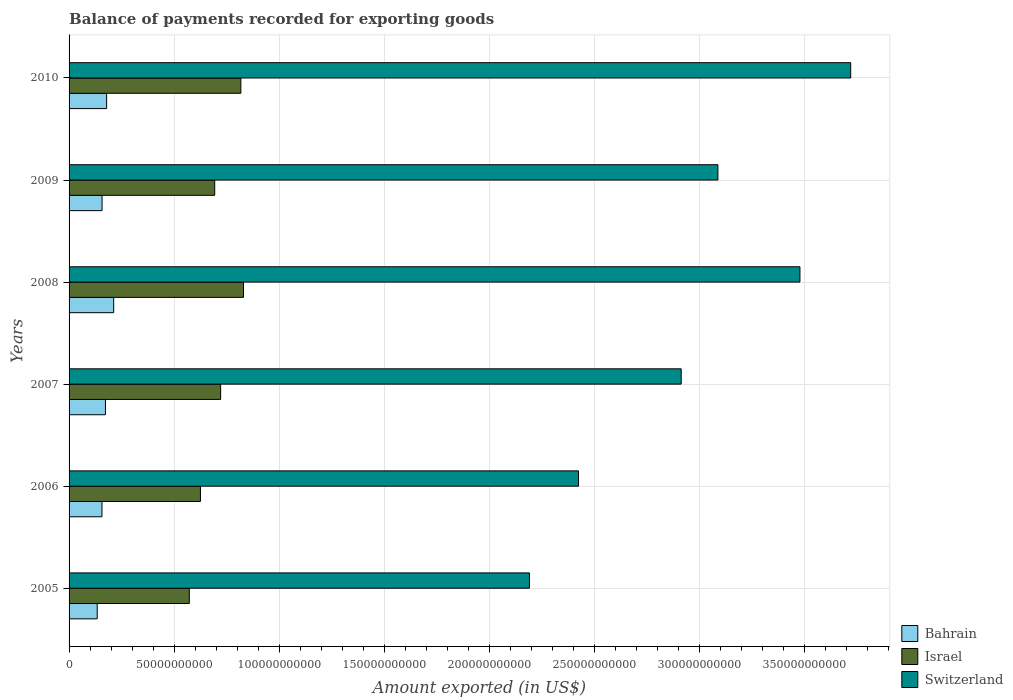How many groups of bars are there?
Keep it short and to the point. 6. Are the number of bars per tick equal to the number of legend labels?
Offer a terse response. Yes. What is the label of the 3rd group of bars from the top?
Offer a very short reply. 2008. What is the amount exported in Switzerland in 2005?
Give a very brief answer. 2.19e+11. Across all years, what is the maximum amount exported in Bahrain?
Provide a succinct answer. 2.12e+1. Across all years, what is the minimum amount exported in Switzerland?
Your answer should be very brief. 2.19e+11. In which year was the amount exported in Israel minimum?
Ensure brevity in your answer.  2005. What is the total amount exported in Switzerland in the graph?
Offer a very short reply. 1.78e+12. What is the difference between the amount exported in Bahrain in 2006 and that in 2009?
Make the answer very short. -4.25e+07. What is the difference between the amount exported in Switzerland in 2006 and the amount exported in Israel in 2007?
Provide a succinct answer. 1.70e+11. What is the average amount exported in Bahrain per year?
Keep it short and to the point. 1.69e+1. In the year 2010, what is the difference between the amount exported in Bahrain and amount exported in Switzerland?
Your answer should be very brief. -3.54e+11. In how many years, is the amount exported in Switzerland greater than 330000000000 US$?
Provide a succinct answer. 2. What is the ratio of the amount exported in Israel in 2009 to that in 2010?
Ensure brevity in your answer.  0.85. What is the difference between the highest and the second highest amount exported in Israel?
Make the answer very short. 1.26e+09. What is the difference between the highest and the lowest amount exported in Israel?
Ensure brevity in your answer.  2.58e+1. Is the sum of the amount exported in Bahrain in 2008 and 2009 greater than the maximum amount exported in Switzerland across all years?
Keep it short and to the point. No. What does the 3rd bar from the top in 2008 represents?
Give a very brief answer. Bahrain. What does the 3rd bar from the bottom in 2010 represents?
Your answer should be very brief. Switzerland. Is it the case that in every year, the sum of the amount exported in Israel and amount exported in Switzerland is greater than the amount exported in Bahrain?
Your answer should be very brief. Yes. How many bars are there?
Ensure brevity in your answer.  18. What is the difference between two consecutive major ticks on the X-axis?
Give a very brief answer. 5.00e+1. How are the legend labels stacked?
Your answer should be compact. Vertical. What is the title of the graph?
Your response must be concise. Balance of payments recorded for exporting goods. Does "Lithuania" appear as one of the legend labels in the graph?
Provide a succinct answer. No. What is the label or title of the X-axis?
Give a very brief answer. Amount exported (in US$). What is the label or title of the Y-axis?
Provide a short and direct response. Years. What is the Amount exported (in US$) of Bahrain in 2005?
Your answer should be very brief. 1.34e+1. What is the Amount exported (in US$) in Israel in 2005?
Offer a terse response. 5.72e+1. What is the Amount exported (in US$) of Switzerland in 2005?
Provide a succinct answer. 2.19e+11. What is the Amount exported (in US$) of Bahrain in 2006?
Your answer should be compact. 1.57e+1. What is the Amount exported (in US$) in Israel in 2006?
Give a very brief answer. 6.26e+1. What is the Amount exported (in US$) of Switzerland in 2006?
Provide a short and direct response. 2.43e+11. What is the Amount exported (in US$) of Bahrain in 2007?
Your answer should be very brief. 1.73e+1. What is the Amount exported (in US$) of Israel in 2007?
Your answer should be very brief. 7.22e+1. What is the Amount exported (in US$) in Switzerland in 2007?
Give a very brief answer. 2.91e+11. What is the Amount exported (in US$) of Bahrain in 2008?
Give a very brief answer. 2.12e+1. What is the Amount exported (in US$) of Israel in 2008?
Provide a short and direct response. 8.30e+1. What is the Amount exported (in US$) in Switzerland in 2008?
Offer a very short reply. 3.48e+11. What is the Amount exported (in US$) in Bahrain in 2009?
Provide a succinct answer. 1.57e+1. What is the Amount exported (in US$) in Israel in 2009?
Provide a succinct answer. 6.93e+1. What is the Amount exported (in US$) in Switzerland in 2009?
Offer a terse response. 3.09e+11. What is the Amount exported (in US$) in Bahrain in 2010?
Make the answer very short. 1.79e+1. What is the Amount exported (in US$) in Israel in 2010?
Your answer should be compact. 8.18e+1. What is the Amount exported (in US$) of Switzerland in 2010?
Provide a succinct answer. 3.72e+11. Across all years, what is the maximum Amount exported (in US$) of Bahrain?
Offer a terse response. 2.12e+1. Across all years, what is the maximum Amount exported (in US$) of Israel?
Your response must be concise. 8.30e+1. Across all years, what is the maximum Amount exported (in US$) in Switzerland?
Your answer should be very brief. 3.72e+11. Across all years, what is the minimum Amount exported (in US$) in Bahrain?
Give a very brief answer. 1.34e+1. Across all years, what is the minimum Amount exported (in US$) in Israel?
Make the answer very short. 5.72e+1. Across all years, what is the minimum Amount exported (in US$) in Switzerland?
Your response must be concise. 2.19e+11. What is the total Amount exported (in US$) of Bahrain in the graph?
Offer a very short reply. 1.01e+11. What is the total Amount exported (in US$) in Israel in the graph?
Your answer should be compact. 4.26e+11. What is the total Amount exported (in US$) of Switzerland in the graph?
Keep it short and to the point. 1.78e+12. What is the difference between the Amount exported (in US$) in Bahrain in 2005 and that in 2006?
Make the answer very short. -2.27e+09. What is the difference between the Amount exported (in US$) in Israel in 2005 and that in 2006?
Provide a succinct answer. -5.30e+09. What is the difference between the Amount exported (in US$) in Switzerland in 2005 and that in 2006?
Ensure brevity in your answer.  -2.34e+1. What is the difference between the Amount exported (in US$) of Bahrain in 2005 and that in 2007?
Your answer should be very brief. -3.92e+09. What is the difference between the Amount exported (in US$) in Israel in 2005 and that in 2007?
Offer a very short reply. -1.49e+1. What is the difference between the Amount exported (in US$) in Switzerland in 2005 and that in 2007?
Give a very brief answer. -7.23e+1. What is the difference between the Amount exported (in US$) of Bahrain in 2005 and that in 2008?
Your answer should be very brief. -7.83e+09. What is the difference between the Amount exported (in US$) of Israel in 2005 and that in 2008?
Ensure brevity in your answer.  -2.58e+1. What is the difference between the Amount exported (in US$) in Switzerland in 2005 and that in 2008?
Your response must be concise. -1.29e+11. What is the difference between the Amount exported (in US$) in Bahrain in 2005 and that in 2009?
Offer a very short reply. -2.31e+09. What is the difference between the Amount exported (in US$) of Israel in 2005 and that in 2009?
Your response must be concise. -1.21e+1. What is the difference between the Amount exported (in US$) in Switzerland in 2005 and that in 2009?
Provide a succinct answer. -8.97e+1. What is the difference between the Amount exported (in US$) in Bahrain in 2005 and that in 2010?
Your answer should be very brief. -4.48e+09. What is the difference between the Amount exported (in US$) in Israel in 2005 and that in 2010?
Ensure brevity in your answer.  -2.45e+1. What is the difference between the Amount exported (in US$) of Switzerland in 2005 and that in 2010?
Provide a short and direct response. -1.53e+11. What is the difference between the Amount exported (in US$) of Bahrain in 2006 and that in 2007?
Offer a very short reply. -1.65e+09. What is the difference between the Amount exported (in US$) of Israel in 2006 and that in 2007?
Provide a succinct answer. -9.61e+09. What is the difference between the Amount exported (in US$) in Switzerland in 2006 and that in 2007?
Make the answer very short. -4.89e+1. What is the difference between the Amount exported (in US$) of Bahrain in 2006 and that in 2008?
Offer a terse response. -5.57e+09. What is the difference between the Amount exported (in US$) in Israel in 2006 and that in 2008?
Provide a short and direct response. -2.05e+1. What is the difference between the Amount exported (in US$) of Switzerland in 2006 and that in 2008?
Make the answer very short. -1.05e+11. What is the difference between the Amount exported (in US$) in Bahrain in 2006 and that in 2009?
Make the answer very short. -4.25e+07. What is the difference between the Amount exported (in US$) of Israel in 2006 and that in 2009?
Keep it short and to the point. -6.79e+09. What is the difference between the Amount exported (in US$) in Switzerland in 2006 and that in 2009?
Provide a succinct answer. -6.64e+1. What is the difference between the Amount exported (in US$) in Bahrain in 2006 and that in 2010?
Offer a very short reply. -2.22e+09. What is the difference between the Amount exported (in US$) of Israel in 2006 and that in 2010?
Ensure brevity in your answer.  -1.92e+1. What is the difference between the Amount exported (in US$) in Switzerland in 2006 and that in 2010?
Provide a short and direct response. -1.30e+11. What is the difference between the Amount exported (in US$) of Bahrain in 2007 and that in 2008?
Your answer should be very brief. -3.92e+09. What is the difference between the Amount exported (in US$) of Israel in 2007 and that in 2008?
Offer a very short reply. -1.09e+1. What is the difference between the Amount exported (in US$) of Switzerland in 2007 and that in 2008?
Your response must be concise. -5.65e+1. What is the difference between the Amount exported (in US$) in Bahrain in 2007 and that in 2009?
Offer a very short reply. 1.61e+09. What is the difference between the Amount exported (in US$) in Israel in 2007 and that in 2009?
Your answer should be very brief. 2.82e+09. What is the difference between the Amount exported (in US$) in Switzerland in 2007 and that in 2009?
Your response must be concise. -1.75e+1. What is the difference between the Amount exported (in US$) in Bahrain in 2007 and that in 2010?
Keep it short and to the point. -5.66e+08. What is the difference between the Amount exported (in US$) of Israel in 2007 and that in 2010?
Offer a terse response. -9.62e+09. What is the difference between the Amount exported (in US$) of Switzerland in 2007 and that in 2010?
Provide a short and direct response. -8.07e+1. What is the difference between the Amount exported (in US$) in Bahrain in 2008 and that in 2009?
Your answer should be very brief. 5.53e+09. What is the difference between the Amount exported (in US$) in Israel in 2008 and that in 2009?
Offer a very short reply. 1.37e+1. What is the difference between the Amount exported (in US$) of Switzerland in 2008 and that in 2009?
Your answer should be very brief. 3.91e+1. What is the difference between the Amount exported (in US$) in Bahrain in 2008 and that in 2010?
Your answer should be compact. 3.35e+09. What is the difference between the Amount exported (in US$) in Israel in 2008 and that in 2010?
Offer a terse response. 1.26e+09. What is the difference between the Amount exported (in US$) in Switzerland in 2008 and that in 2010?
Your response must be concise. -2.42e+1. What is the difference between the Amount exported (in US$) in Bahrain in 2009 and that in 2010?
Provide a short and direct response. -2.18e+09. What is the difference between the Amount exported (in US$) of Israel in 2009 and that in 2010?
Ensure brevity in your answer.  -1.24e+1. What is the difference between the Amount exported (in US$) of Switzerland in 2009 and that in 2010?
Make the answer very short. -6.32e+1. What is the difference between the Amount exported (in US$) of Bahrain in 2005 and the Amount exported (in US$) of Israel in 2006?
Provide a short and direct response. -4.92e+1. What is the difference between the Amount exported (in US$) of Bahrain in 2005 and the Amount exported (in US$) of Switzerland in 2006?
Give a very brief answer. -2.29e+11. What is the difference between the Amount exported (in US$) of Israel in 2005 and the Amount exported (in US$) of Switzerland in 2006?
Your response must be concise. -1.85e+11. What is the difference between the Amount exported (in US$) in Bahrain in 2005 and the Amount exported (in US$) in Israel in 2007?
Offer a terse response. -5.88e+1. What is the difference between the Amount exported (in US$) in Bahrain in 2005 and the Amount exported (in US$) in Switzerland in 2007?
Your answer should be compact. -2.78e+11. What is the difference between the Amount exported (in US$) of Israel in 2005 and the Amount exported (in US$) of Switzerland in 2007?
Your answer should be very brief. -2.34e+11. What is the difference between the Amount exported (in US$) in Bahrain in 2005 and the Amount exported (in US$) in Israel in 2008?
Provide a short and direct response. -6.96e+1. What is the difference between the Amount exported (in US$) of Bahrain in 2005 and the Amount exported (in US$) of Switzerland in 2008?
Provide a short and direct response. -3.35e+11. What is the difference between the Amount exported (in US$) of Israel in 2005 and the Amount exported (in US$) of Switzerland in 2008?
Make the answer very short. -2.91e+11. What is the difference between the Amount exported (in US$) in Bahrain in 2005 and the Amount exported (in US$) in Israel in 2009?
Make the answer very short. -5.59e+1. What is the difference between the Amount exported (in US$) of Bahrain in 2005 and the Amount exported (in US$) of Switzerland in 2009?
Provide a short and direct response. -2.96e+11. What is the difference between the Amount exported (in US$) in Israel in 2005 and the Amount exported (in US$) in Switzerland in 2009?
Ensure brevity in your answer.  -2.52e+11. What is the difference between the Amount exported (in US$) in Bahrain in 2005 and the Amount exported (in US$) in Israel in 2010?
Your answer should be very brief. -6.84e+1. What is the difference between the Amount exported (in US$) in Bahrain in 2005 and the Amount exported (in US$) in Switzerland in 2010?
Your answer should be very brief. -3.59e+11. What is the difference between the Amount exported (in US$) of Israel in 2005 and the Amount exported (in US$) of Switzerland in 2010?
Your answer should be very brief. -3.15e+11. What is the difference between the Amount exported (in US$) of Bahrain in 2006 and the Amount exported (in US$) of Israel in 2007?
Your answer should be compact. -5.65e+1. What is the difference between the Amount exported (in US$) of Bahrain in 2006 and the Amount exported (in US$) of Switzerland in 2007?
Ensure brevity in your answer.  -2.76e+11. What is the difference between the Amount exported (in US$) in Israel in 2006 and the Amount exported (in US$) in Switzerland in 2007?
Offer a terse response. -2.29e+11. What is the difference between the Amount exported (in US$) in Bahrain in 2006 and the Amount exported (in US$) in Israel in 2008?
Your answer should be compact. -6.74e+1. What is the difference between the Amount exported (in US$) in Bahrain in 2006 and the Amount exported (in US$) in Switzerland in 2008?
Your response must be concise. -3.32e+11. What is the difference between the Amount exported (in US$) in Israel in 2006 and the Amount exported (in US$) in Switzerland in 2008?
Ensure brevity in your answer.  -2.85e+11. What is the difference between the Amount exported (in US$) in Bahrain in 2006 and the Amount exported (in US$) in Israel in 2009?
Your answer should be compact. -5.37e+1. What is the difference between the Amount exported (in US$) in Bahrain in 2006 and the Amount exported (in US$) in Switzerland in 2009?
Your answer should be compact. -2.93e+11. What is the difference between the Amount exported (in US$) in Israel in 2006 and the Amount exported (in US$) in Switzerland in 2009?
Provide a short and direct response. -2.46e+11. What is the difference between the Amount exported (in US$) in Bahrain in 2006 and the Amount exported (in US$) in Israel in 2010?
Make the answer very short. -6.61e+1. What is the difference between the Amount exported (in US$) of Bahrain in 2006 and the Amount exported (in US$) of Switzerland in 2010?
Make the answer very short. -3.56e+11. What is the difference between the Amount exported (in US$) in Israel in 2006 and the Amount exported (in US$) in Switzerland in 2010?
Offer a very short reply. -3.10e+11. What is the difference between the Amount exported (in US$) in Bahrain in 2007 and the Amount exported (in US$) in Israel in 2008?
Your answer should be very brief. -6.57e+1. What is the difference between the Amount exported (in US$) of Bahrain in 2007 and the Amount exported (in US$) of Switzerland in 2008?
Keep it short and to the point. -3.31e+11. What is the difference between the Amount exported (in US$) of Israel in 2007 and the Amount exported (in US$) of Switzerland in 2008?
Your response must be concise. -2.76e+11. What is the difference between the Amount exported (in US$) in Bahrain in 2007 and the Amount exported (in US$) in Israel in 2009?
Ensure brevity in your answer.  -5.20e+1. What is the difference between the Amount exported (in US$) of Bahrain in 2007 and the Amount exported (in US$) of Switzerland in 2009?
Ensure brevity in your answer.  -2.92e+11. What is the difference between the Amount exported (in US$) of Israel in 2007 and the Amount exported (in US$) of Switzerland in 2009?
Your answer should be compact. -2.37e+11. What is the difference between the Amount exported (in US$) in Bahrain in 2007 and the Amount exported (in US$) in Israel in 2010?
Offer a very short reply. -6.45e+1. What is the difference between the Amount exported (in US$) of Bahrain in 2007 and the Amount exported (in US$) of Switzerland in 2010?
Your response must be concise. -3.55e+11. What is the difference between the Amount exported (in US$) of Israel in 2007 and the Amount exported (in US$) of Switzerland in 2010?
Your response must be concise. -3.00e+11. What is the difference between the Amount exported (in US$) of Bahrain in 2008 and the Amount exported (in US$) of Israel in 2009?
Provide a short and direct response. -4.81e+1. What is the difference between the Amount exported (in US$) of Bahrain in 2008 and the Amount exported (in US$) of Switzerland in 2009?
Provide a succinct answer. -2.88e+11. What is the difference between the Amount exported (in US$) in Israel in 2008 and the Amount exported (in US$) in Switzerland in 2009?
Provide a short and direct response. -2.26e+11. What is the difference between the Amount exported (in US$) of Bahrain in 2008 and the Amount exported (in US$) of Israel in 2010?
Your response must be concise. -6.06e+1. What is the difference between the Amount exported (in US$) of Bahrain in 2008 and the Amount exported (in US$) of Switzerland in 2010?
Keep it short and to the point. -3.51e+11. What is the difference between the Amount exported (in US$) of Israel in 2008 and the Amount exported (in US$) of Switzerland in 2010?
Provide a succinct answer. -2.89e+11. What is the difference between the Amount exported (in US$) in Bahrain in 2009 and the Amount exported (in US$) in Israel in 2010?
Provide a short and direct response. -6.61e+1. What is the difference between the Amount exported (in US$) of Bahrain in 2009 and the Amount exported (in US$) of Switzerland in 2010?
Provide a succinct answer. -3.56e+11. What is the difference between the Amount exported (in US$) in Israel in 2009 and the Amount exported (in US$) in Switzerland in 2010?
Make the answer very short. -3.03e+11. What is the average Amount exported (in US$) in Bahrain per year?
Provide a short and direct response. 1.69e+1. What is the average Amount exported (in US$) of Israel per year?
Provide a succinct answer. 7.10e+1. What is the average Amount exported (in US$) of Switzerland per year?
Provide a succinct answer. 2.97e+11. In the year 2005, what is the difference between the Amount exported (in US$) of Bahrain and Amount exported (in US$) of Israel?
Your answer should be compact. -4.39e+1. In the year 2005, what is the difference between the Amount exported (in US$) of Bahrain and Amount exported (in US$) of Switzerland?
Offer a terse response. -2.06e+11. In the year 2005, what is the difference between the Amount exported (in US$) of Israel and Amount exported (in US$) of Switzerland?
Provide a succinct answer. -1.62e+11. In the year 2006, what is the difference between the Amount exported (in US$) in Bahrain and Amount exported (in US$) in Israel?
Offer a very short reply. -4.69e+1. In the year 2006, what is the difference between the Amount exported (in US$) of Bahrain and Amount exported (in US$) of Switzerland?
Ensure brevity in your answer.  -2.27e+11. In the year 2006, what is the difference between the Amount exported (in US$) of Israel and Amount exported (in US$) of Switzerland?
Provide a succinct answer. -1.80e+11. In the year 2007, what is the difference between the Amount exported (in US$) in Bahrain and Amount exported (in US$) in Israel?
Your answer should be very brief. -5.48e+1. In the year 2007, what is the difference between the Amount exported (in US$) in Bahrain and Amount exported (in US$) in Switzerland?
Give a very brief answer. -2.74e+11. In the year 2007, what is the difference between the Amount exported (in US$) of Israel and Amount exported (in US$) of Switzerland?
Offer a terse response. -2.19e+11. In the year 2008, what is the difference between the Amount exported (in US$) in Bahrain and Amount exported (in US$) in Israel?
Offer a very short reply. -6.18e+1. In the year 2008, what is the difference between the Amount exported (in US$) of Bahrain and Amount exported (in US$) of Switzerland?
Your answer should be compact. -3.27e+11. In the year 2008, what is the difference between the Amount exported (in US$) in Israel and Amount exported (in US$) in Switzerland?
Provide a succinct answer. -2.65e+11. In the year 2009, what is the difference between the Amount exported (in US$) in Bahrain and Amount exported (in US$) in Israel?
Offer a terse response. -5.36e+1. In the year 2009, what is the difference between the Amount exported (in US$) of Bahrain and Amount exported (in US$) of Switzerland?
Provide a succinct answer. -2.93e+11. In the year 2009, what is the difference between the Amount exported (in US$) of Israel and Amount exported (in US$) of Switzerland?
Offer a very short reply. -2.40e+11. In the year 2010, what is the difference between the Amount exported (in US$) in Bahrain and Amount exported (in US$) in Israel?
Offer a terse response. -6.39e+1. In the year 2010, what is the difference between the Amount exported (in US$) of Bahrain and Amount exported (in US$) of Switzerland?
Offer a terse response. -3.54e+11. In the year 2010, what is the difference between the Amount exported (in US$) in Israel and Amount exported (in US$) in Switzerland?
Your response must be concise. -2.90e+11. What is the ratio of the Amount exported (in US$) in Bahrain in 2005 to that in 2006?
Your response must be concise. 0.86. What is the ratio of the Amount exported (in US$) in Israel in 2005 to that in 2006?
Provide a succinct answer. 0.92. What is the ratio of the Amount exported (in US$) in Switzerland in 2005 to that in 2006?
Provide a succinct answer. 0.9. What is the ratio of the Amount exported (in US$) in Bahrain in 2005 to that in 2007?
Provide a succinct answer. 0.77. What is the ratio of the Amount exported (in US$) of Israel in 2005 to that in 2007?
Your response must be concise. 0.79. What is the ratio of the Amount exported (in US$) in Switzerland in 2005 to that in 2007?
Provide a succinct answer. 0.75. What is the ratio of the Amount exported (in US$) of Bahrain in 2005 to that in 2008?
Give a very brief answer. 0.63. What is the ratio of the Amount exported (in US$) of Israel in 2005 to that in 2008?
Your answer should be very brief. 0.69. What is the ratio of the Amount exported (in US$) of Switzerland in 2005 to that in 2008?
Your answer should be very brief. 0.63. What is the ratio of the Amount exported (in US$) of Bahrain in 2005 to that in 2009?
Make the answer very short. 0.85. What is the ratio of the Amount exported (in US$) of Israel in 2005 to that in 2009?
Your response must be concise. 0.83. What is the ratio of the Amount exported (in US$) in Switzerland in 2005 to that in 2009?
Your answer should be compact. 0.71. What is the ratio of the Amount exported (in US$) of Bahrain in 2005 to that in 2010?
Offer a terse response. 0.75. What is the ratio of the Amount exported (in US$) of Israel in 2005 to that in 2010?
Your answer should be very brief. 0.7. What is the ratio of the Amount exported (in US$) in Switzerland in 2005 to that in 2010?
Ensure brevity in your answer.  0.59. What is the ratio of the Amount exported (in US$) in Bahrain in 2006 to that in 2007?
Make the answer very short. 0.9. What is the ratio of the Amount exported (in US$) of Israel in 2006 to that in 2007?
Give a very brief answer. 0.87. What is the ratio of the Amount exported (in US$) of Switzerland in 2006 to that in 2007?
Provide a short and direct response. 0.83. What is the ratio of the Amount exported (in US$) of Bahrain in 2006 to that in 2008?
Your answer should be compact. 0.74. What is the ratio of the Amount exported (in US$) in Israel in 2006 to that in 2008?
Your answer should be compact. 0.75. What is the ratio of the Amount exported (in US$) in Switzerland in 2006 to that in 2008?
Your answer should be very brief. 0.7. What is the ratio of the Amount exported (in US$) of Bahrain in 2006 to that in 2009?
Make the answer very short. 1. What is the ratio of the Amount exported (in US$) in Israel in 2006 to that in 2009?
Provide a short and direct response. 0.9. What is the ratio of the Amount exported (in US$) in Switzerland in 2006 to that in 2009?
Offer a very short reply. 0.79. What is the ratio of the Amount exported (in US$) in Bahrain in 2006 to that in 2010?
Your response must be concise. 0.88. What is the ratio of the Amount exported (in US$) of Israel in 2006 to that in 2010?
Keep it short and to the point. 0.76. What is the ratio of the Amount exported (in US$) of Switzerland in 2006 to that in 2010?
Your response must be concise. 0.65. What is the ratio of the Amount exported (in US$) of Bahrain in 2007 to that in 2008?
Your answer should be compact. 0.82. What is the ratio of the Amount exported (in US$) of Israel in 2007 to that in 2008?
Your answer should be very brief. 0.87. What is the ratio of the Amount exported (in US$) of Switzerland in 2007 to that in 2008?
Your answer should be very brief. 0.84. What is the ratio of the Amount exported (in US$) in Bahrain in 2007 to that in 2009?
Offer a very short reply. 1.1. What is the ratio of the Amount exported (in US$) of Israel in 2007 to that in 2009?
Ensure brevity in your answer.  1.04. What is the ratio of the Amount exported (in US$) in Switzerland in 2007 to that in 2009?
Make the answer very short. 0.94. What is the ratio of the Amount exported (in US$) of Bahrain in 2007 to that in 2010?
Give a very brief answer. 0.97. What is the ratio of the Amount exported (in US$) of Israel in 2007 to that in 2010?
Your answer should be very brief. 0.88. What is the ratio of the Amount exported (in US$) in Switzerland in 2007 to that in 2010?
Your answer should be very brief. 0.78. What is the ratio of the Amount exported (in US$) of Bahrain in 2008 to that in 2009?
Your response must be concise. 1.35. What is the ratio of the Amount exported (in US$) of Israel in 2008 to that in 2009?
Provide a succinct answer. 1.2. What is the ratio of the Amount exported (in US$) of Switzerland in 2008 to that in 2009?
Your answer should be very brief. 1.13. What is the ratio of the Amount exported (in US$) in Bahrain in 2008 to that in 2010?
Give a very brief answer. 1.19. What is the ratio of the Amount exported (in US$) of Israel in 2008 to that in 2010?
Provide a succinct answer. 1.02. What is the ratio of the Amount exported (in US$) in Switzerland in 2008 to that in 2010?
Your answer should be very brief. 0.94. What is the ratio of the Amount exported (in US$) in Bahrain in 2009 to that in 2010?
Make the answer very short. 0.88. What is the ratio of the Amount exported (in US$) in Israel in 2009 to that in 2010?
Give a very brief answer. 0.85. What is the ratio of the Amount exported (in US$) of Switzerland in 2009 to that in 2010?
Make the answer very short. 0.83. What is the difference between the highest and the second highest Amount exported (in US$) in Bahrain?
Make the answer very short. 3.35e+09. What is the difference between the highest and the second highest Amount exported (in US$) of Israel?
Make the answer very short. 1.26e+09. What is the difference between the highest and the second highest Amount exported (in US$) of Switzerland?
Offer a very short reply. 2.42e+1. What is the difference between the highest and the lowest Amount exported (in US$) of Bahrain?
Offer a terse response. 7.83e+09. What is the difference between the highest and the lowest Amount exported (in US$) in Israel?
Give a very brief answer. 2.58e+1. What is the difference between the highest and the lowest Amount exported (in US$) in Switzerland?
Make the answer very short. 1.53e+11. 